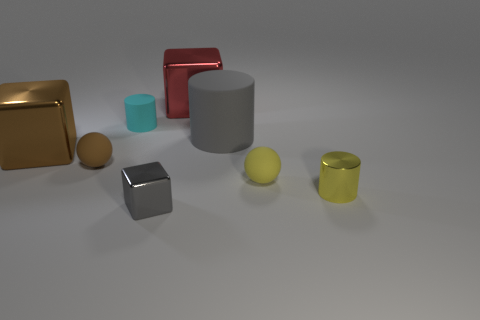Is there an object in the image that looks out of place compared to the others? While most objects in the image have a smooth, solid appearance, the reddish block leaning against the gold cube appears slightly out of place due to its open structure and the fact that it's the only object that is not completely solid. 